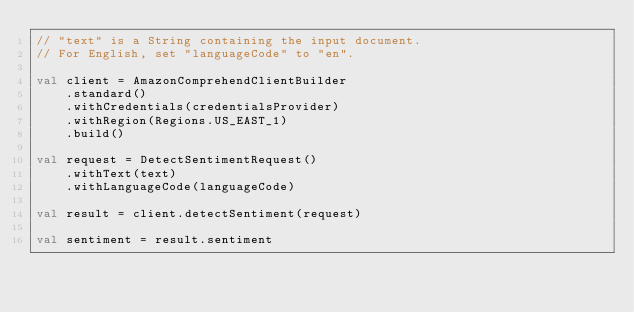Convert code to text. <code><loc_0><loc_0><loc_500><loc_500><_Kotlin_>// "text" is a String containing the input document.
// For English, set "languageCode" to "en".

val client = AmazonComprehendClientBuilder
    .standard()
    .withCredentials(credentialsProvider)
    .withRegion(Regions.US_EAST_1)
    .build()

val request = DetectSentimentRequest()
    .withText(text)
    .withLanguageCode(languageCode)

val result = client.detectSentiment(request)

val sentiment = result.sentiment
</code> 